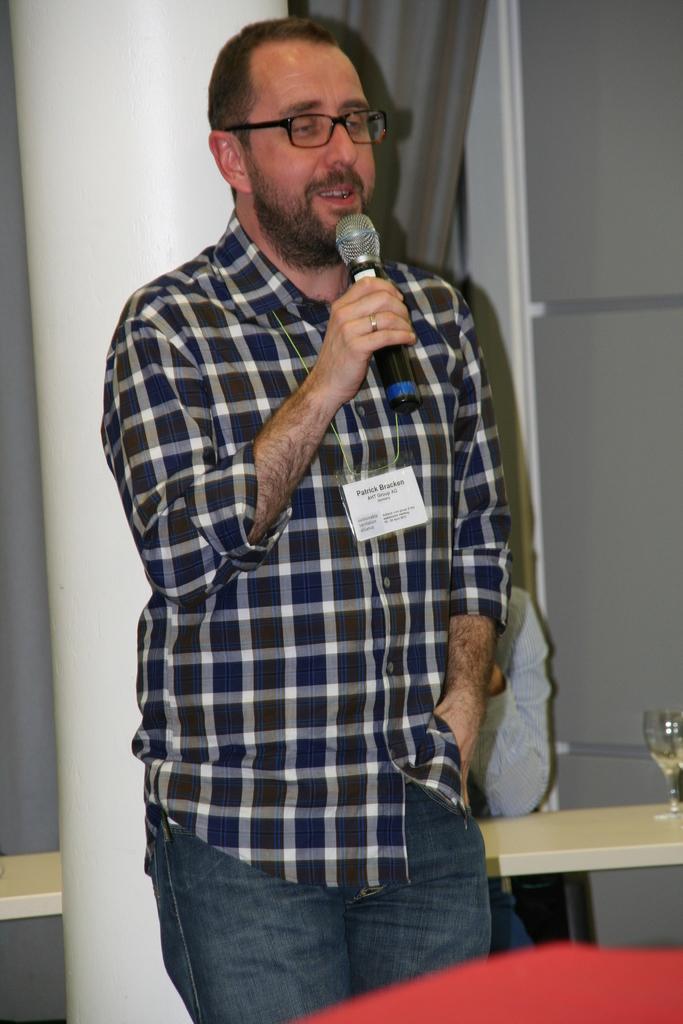In one or two sentences, can you explain what this image depicts? In this image i can see a person standing and holding a microphone in his hand. In the background i can see another person sitting, a wine glass and a curtain. 